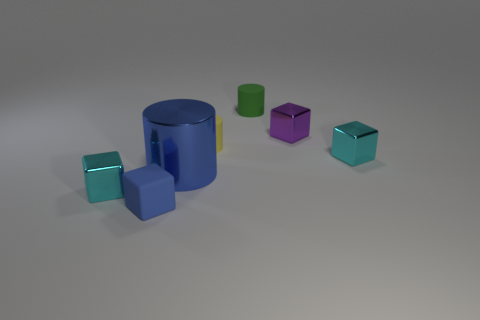Add 2 small cubes. How many objects exist? 9 Subtract all cubes. How many objects are left? 3 Subtract 0 red cylinders. How many objects are left? 7 Subtract all tiny blue matte balls. Subtract all tiny blue things. How many objects are left? 6 Add 6 shiny things. How many shiny things are left? 10 Add 3 small rubber objects. How many small rubber objects exist? 6 